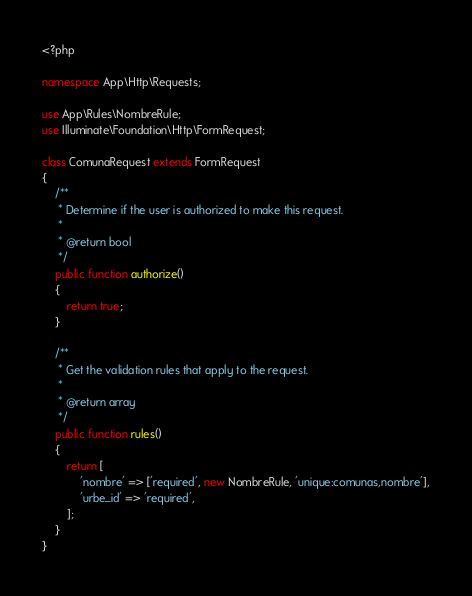Convert code to text. <code><loc_0><loc_0><loc_500><loc_500><_PHP_><?php

namespace App\Http\Requests;

use App\Rules\NombreRule;
use Illuminate\Foundation\Http\FormRequest;

class ComunaRequest extends FormRequest
{
    /**
     * Determine if the user is authorized to make this request.
     *
     * @return bool
     */
    public function authorize()
    {
        return true;
    }

    /**
     * Get the validation rules that apply to the request.
     *
     * @return array
     */
    public function rules()
    {
        return [
            'nombre' => ['required', new NombreRule, 'unique:comunas,nombre'],
            'urbe_id' => 'required',
        ];
    }
}
</code> 